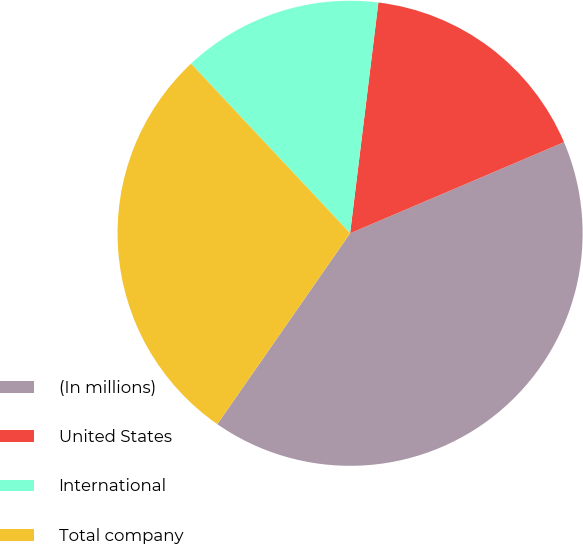<chart> <loc_0><loc_0><loc_500><loc_500><pie_chart><fcel>(In millions)<fcel>United States<fcel>International<fcel>Total company<nl><fcel>41.08%<fcel>16.65%<fcel>13.93%<fcel>28.34%<nl></chart> 